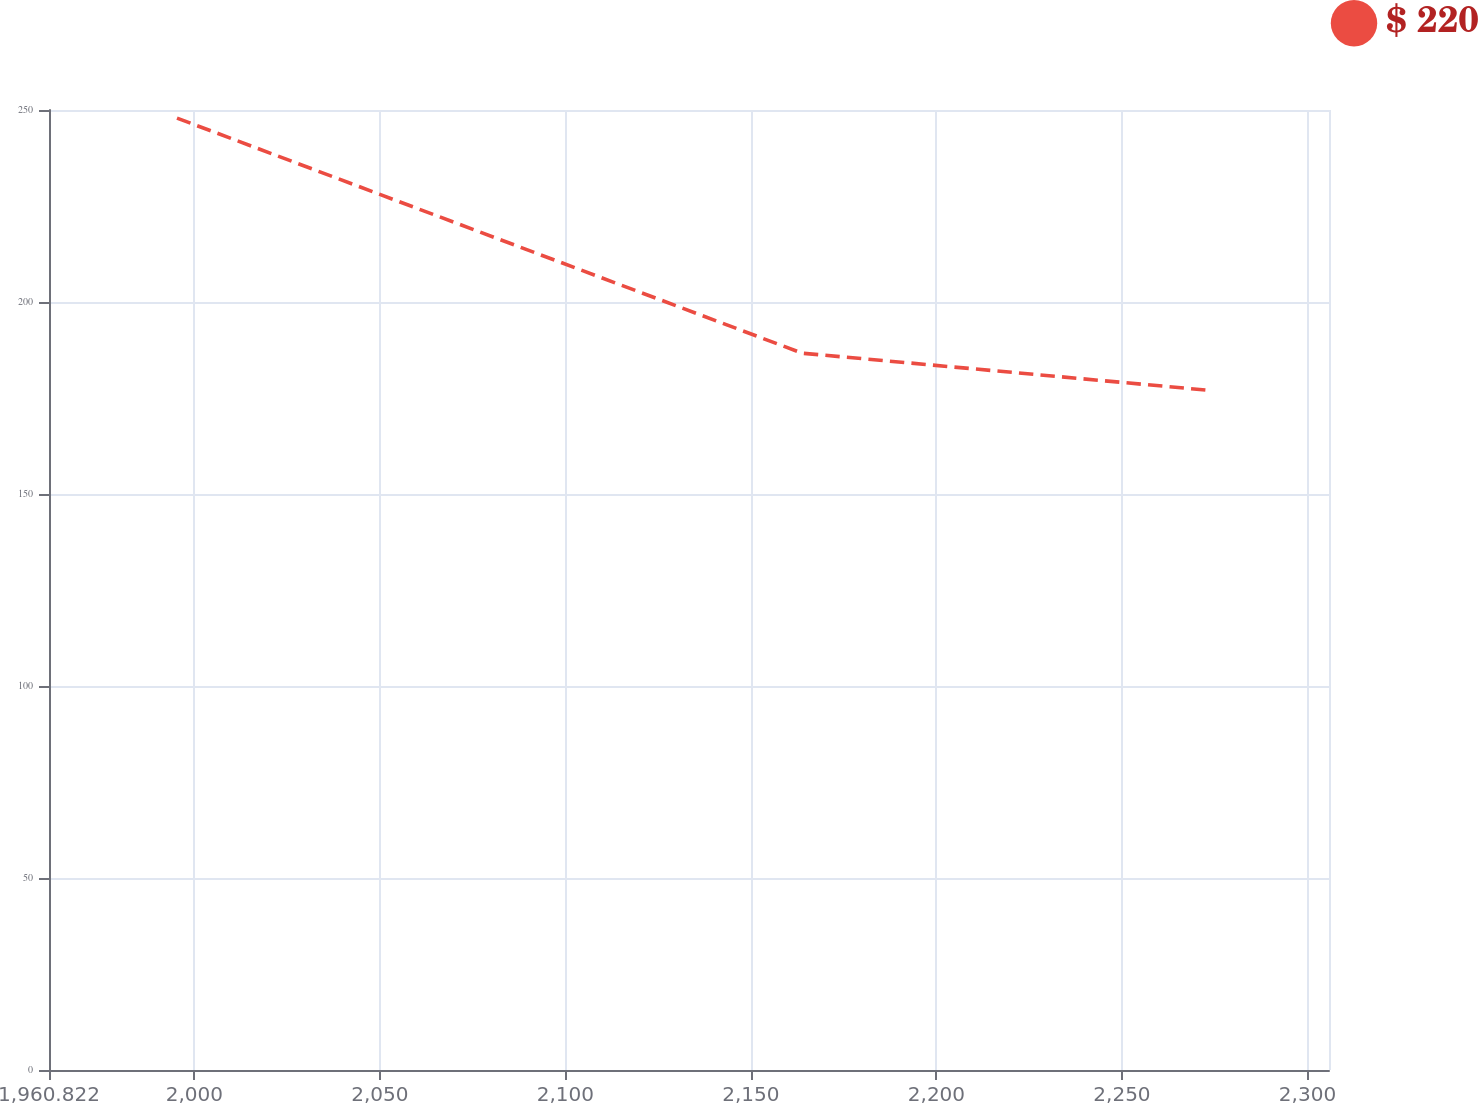<chart> <loc_0><loc_0><loc_500><loc_500><line_chart><ecel><fcel>$ 220<nl><fcel>1995.32<fcel>247.89<nl><fcel>2163.82<fcel>186.67<nl><fcel>2273.99<fcel>176.95<nl><fcel>2340.3<fcel>150.73<nl></chart> 